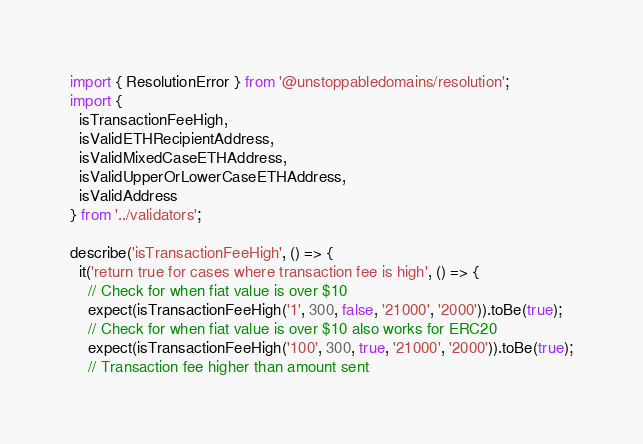Convert code to text. <code><loc_0><loc_0><loc_500><loc_500><_TypeScript_>import { ResolutionError } from '@unstoppabledomains/resolution';
import {
  isTransactionFeeHigh,
  isValidETHRecipientAddress,
  isValidMixedCaseETHAddress,
  isValidUpperOrLowerCaseETHAddress,
  isValidAddress
} from '../validators';

describe('isTransactionFeeHigh', () => {
  it('return true for cases where transaction fee is high', () => {
    // Check for when fiat value is over $10
    expect(isTransactionFeeHigh('1', 300, false, '21000', '2000')).toBe(true);
    // Check for when fiat value is over $10 also works for ERC20
    expect(isTransactionFeeHigh('100', 300, true, '21000', '2000')).toBe(true);
    // Transaction fee higher than amount sent</code> 